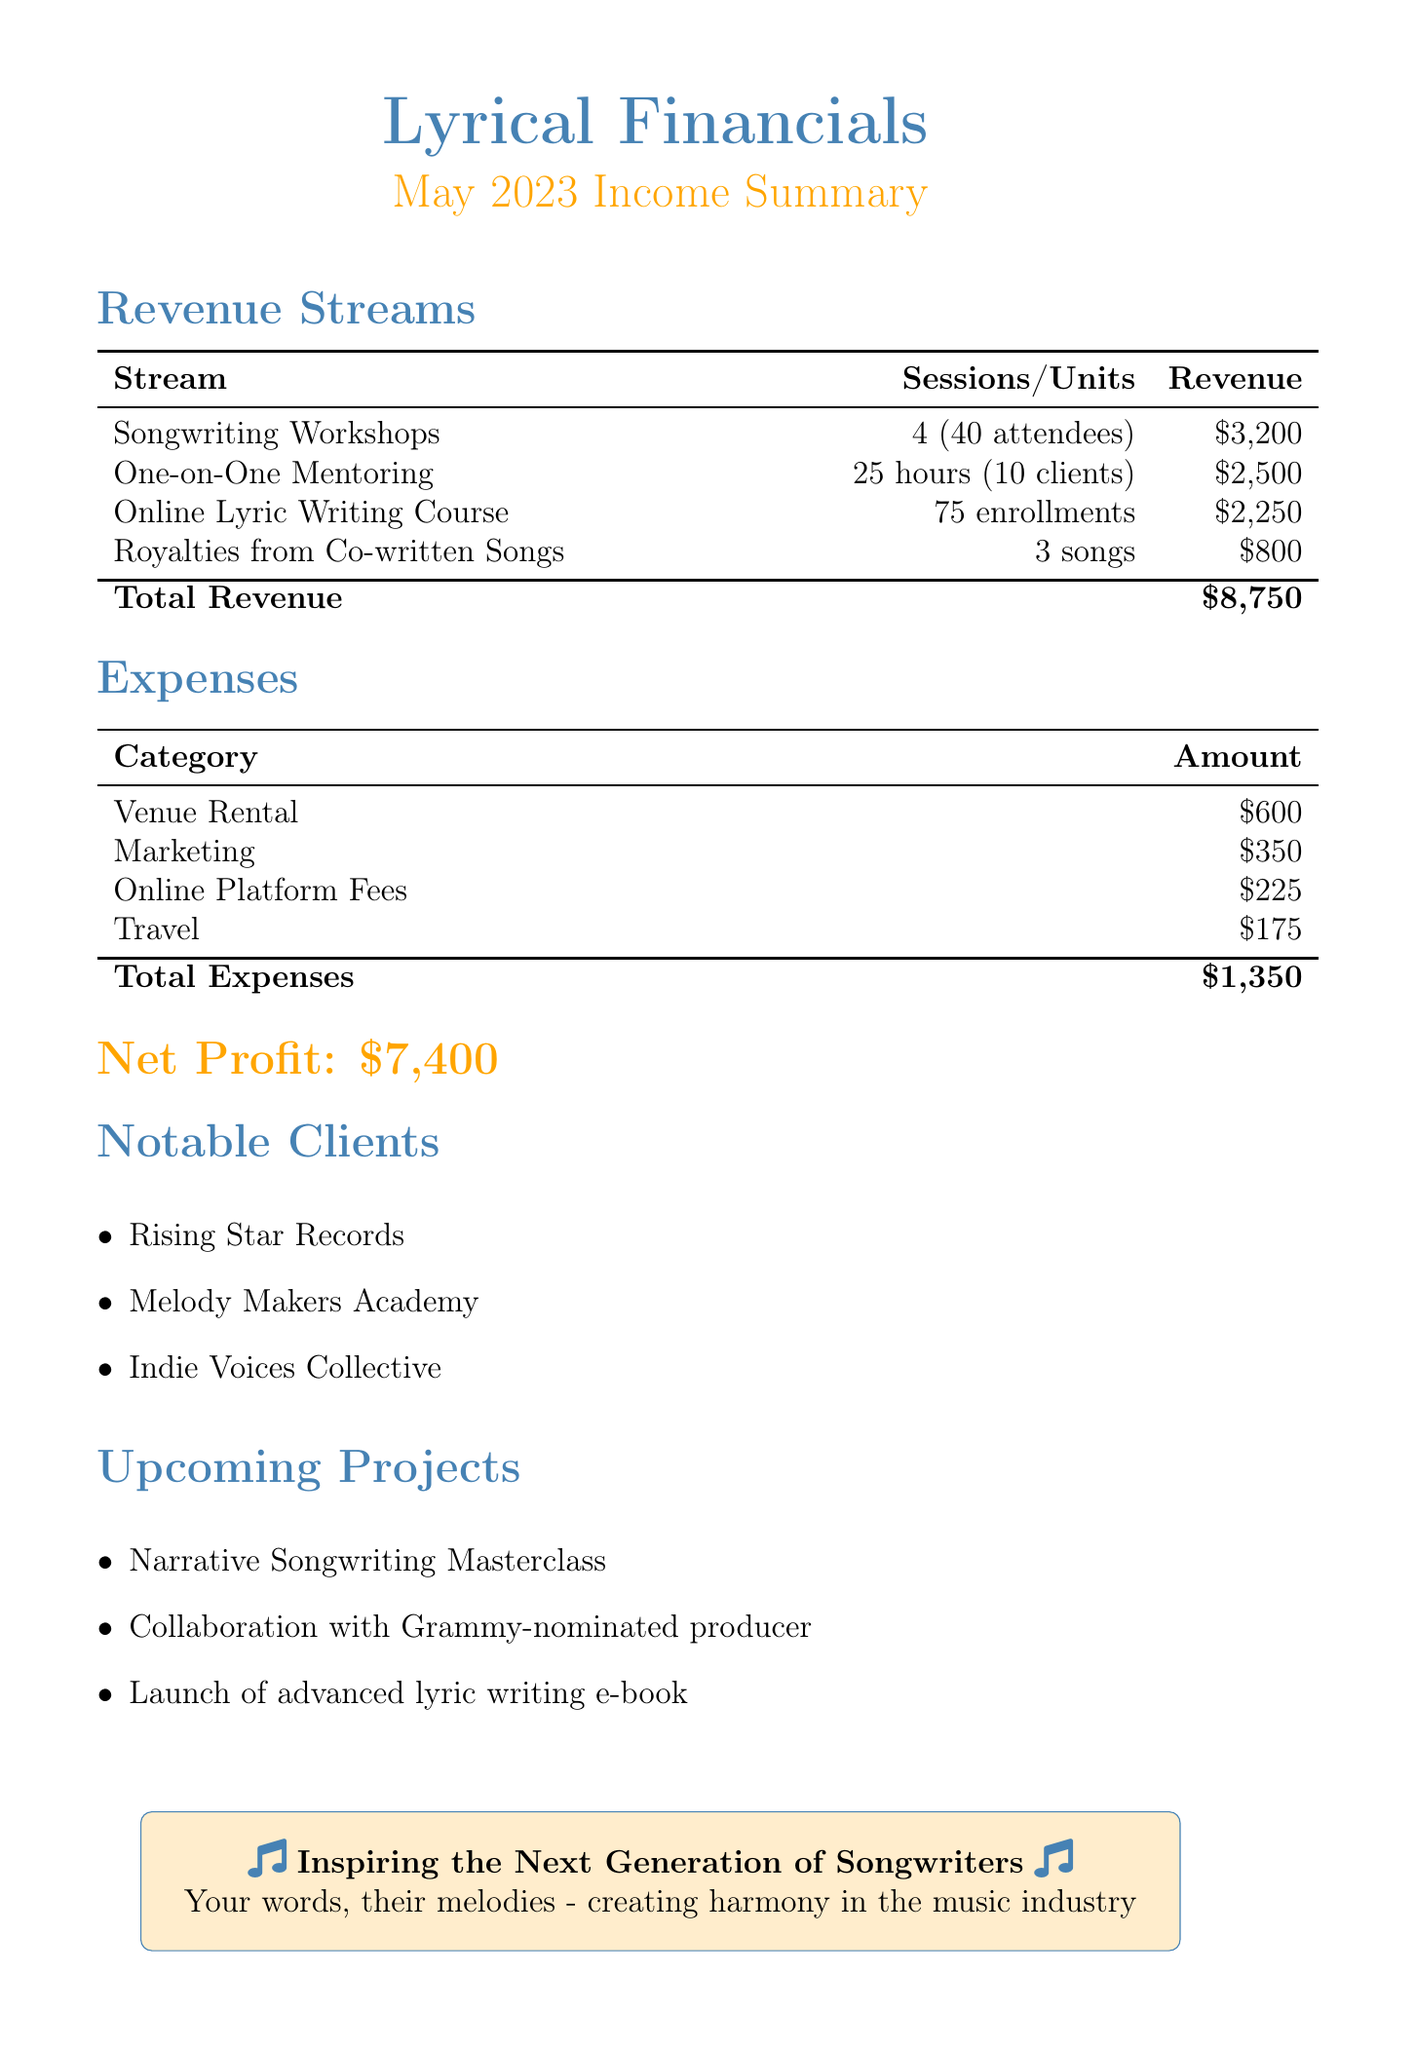What is the total revenue? The total revenue is the sum of all revenue sources in the document, which is $3200 + $2500 + $2250 + $800 = $8750.
Answer: $8750 How many sessions were held for the songwriting workshops? The document indicates that there were 4 sessions held for the songwriting workshops.
Answer: 4 What is the revenue from royalties? The document states that the revenue from royalties from co-written songs is $800.
Answer: $800 How many clients attended one-on-one mentoring sessions? According to the document, there were 10 clients for the one-on-one mentoring sessions.
Answer: 10 What is the total amount spent on expenses? The total expenses are calculated by adding venue rental, marketing, online platform fees, and travel, totaling $600 + $350 + $225 + $175 = $1350.
Answer: $1350 What is the net profit? The net profit is defined as total revenue minus total expenses in the document, which is $8750 - $1350 = $7400.
Answer: $7400 Who are some of the notable clients mentioned? The document lists notable clients, which include Rising Star Records, Melody Makers Academy, and Indie Voices Collective.
Answer: Rising Star Records, Melody Makers Academy, Indie Voices Collective What is one of the upcoming projects? The document mentions upcoming projects, including a Narrative Songwriting Masterclass.
Answer: Narrative Songwriting Masterclass How many enrollments were there for the online lyric writing course? The document states that there were 75 enrollments for the online lyric writing course.
Answer: 75 